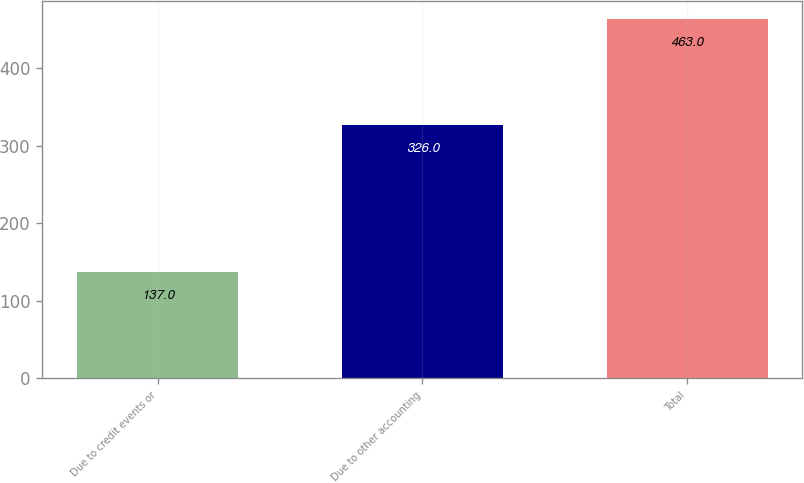<chart> <loc_0><loc_0><loc_500><loc_500><bar_chart><fcel>Due to credit events or<fcel>Due to other accounting<fcel>Total<nl><fcel>137<fcel>326<fcel>463<nl></chart> 